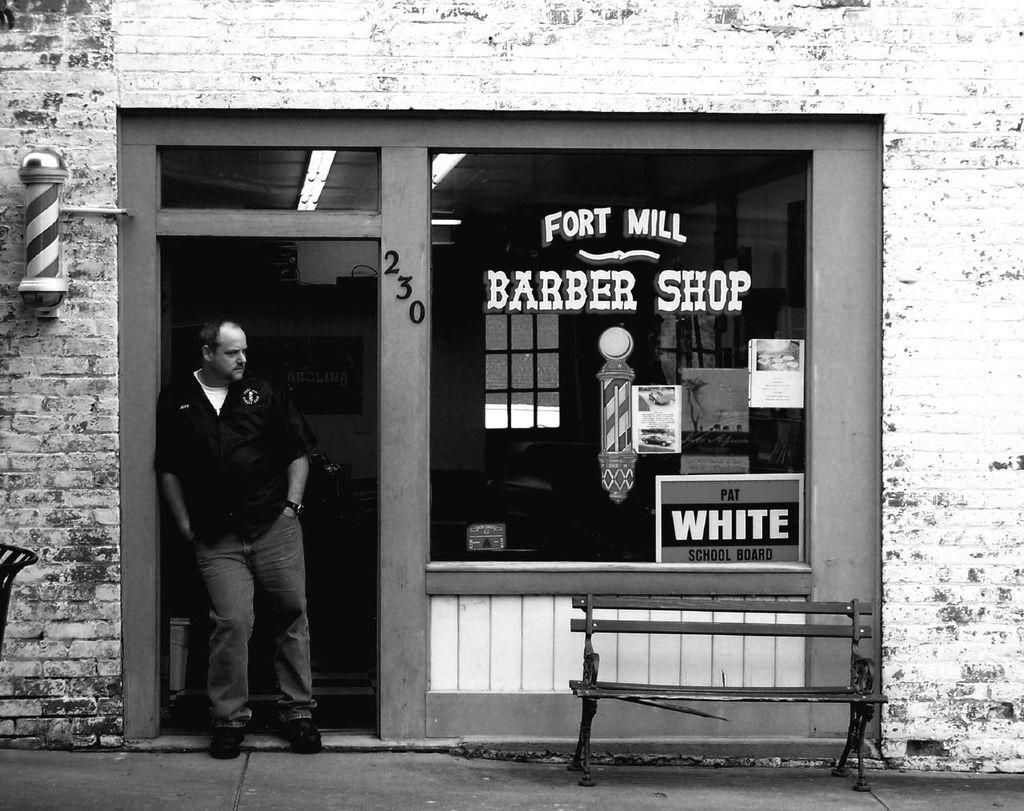What is the main subject of the image? There is a man standing in the image. What can be seen in the background of the image? There is a building in the image. What object is made of glass in the image? There is glass in the image, but it is not specified what object it is part of. What type of seating is present in the image? There is a bench in the image. What type of plants can be seen growing inside the man's stomach in the image? There is no indication of any plants growing inside the man's stomach in the image. 